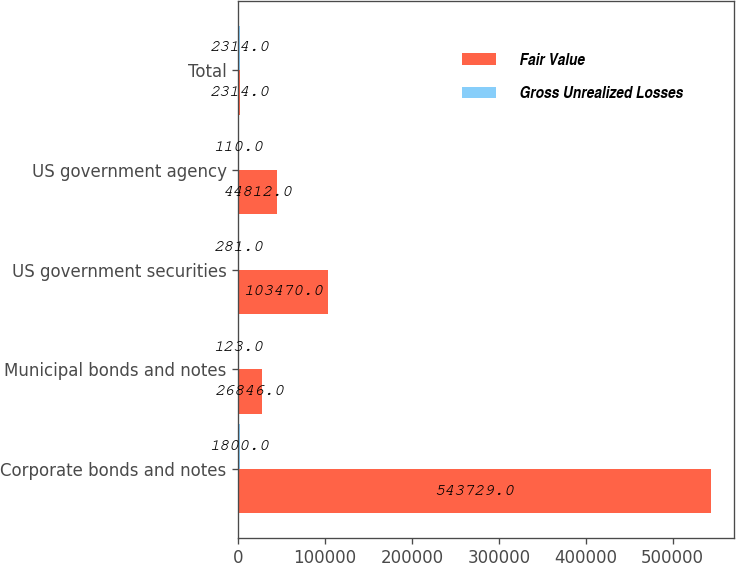<chart> <loc_0><loc_0><loc_500><loc_500><stacked_bar_chart><ecel><fcel>Corporate bonds and notes<fcel>Municipal bonds and notes<fcel>US government securities<fcel>US government agency<fcel>Total<nl><fcel>Fair Value<fcel>543729<fcel>26846<fcel>103470<fcel>44812<fcel>2314<nl><fcel>Gross Unrealized Losses<fcel>1800<fcel>123<fcel>281<fcel>110<fcel>2314<nl></chart> 